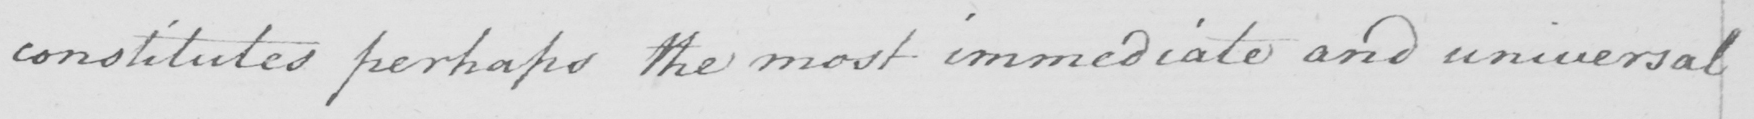What does this handwritten line say? constitutes perhaps the most immediate and universal 